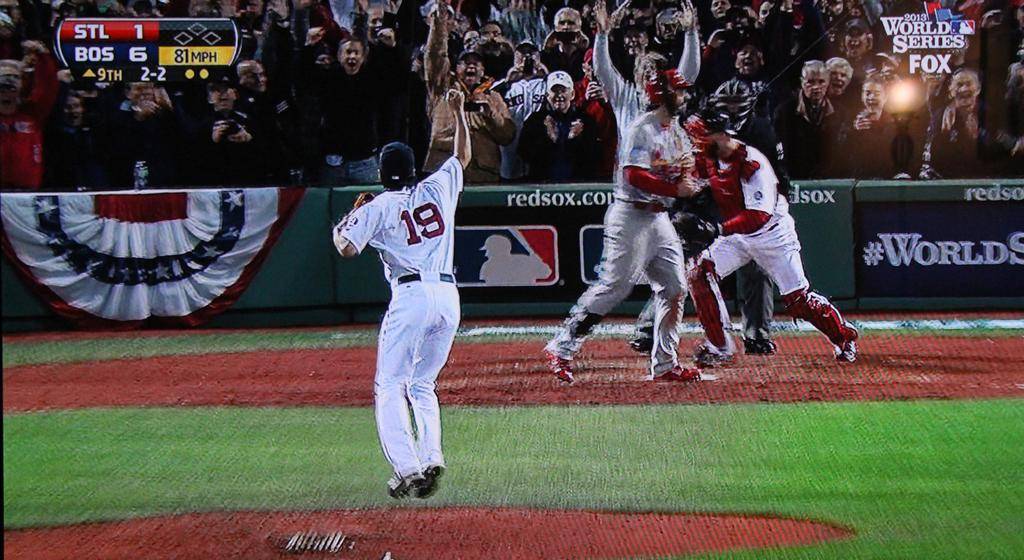<image>
Offer a succinct explanation of the picture presented. Baseball player wearing number 19 with his fists in the air celebrating. 